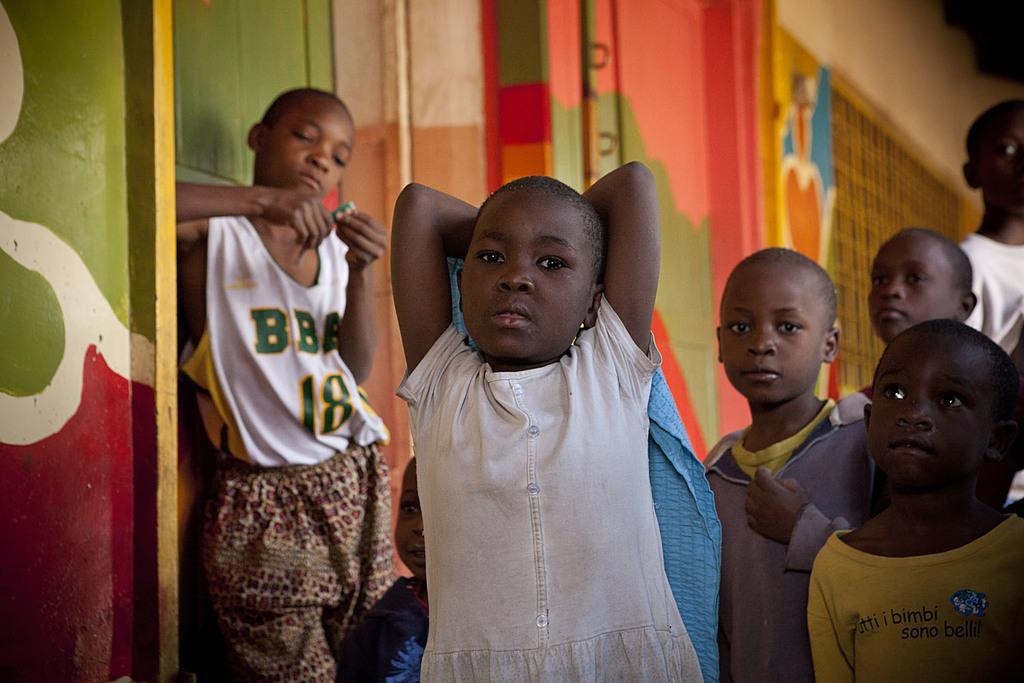Could you give a brief overview of what you see in this image? In this image I can see the group of people with different color dresses. To the side of these people I can see the colorful wall. 